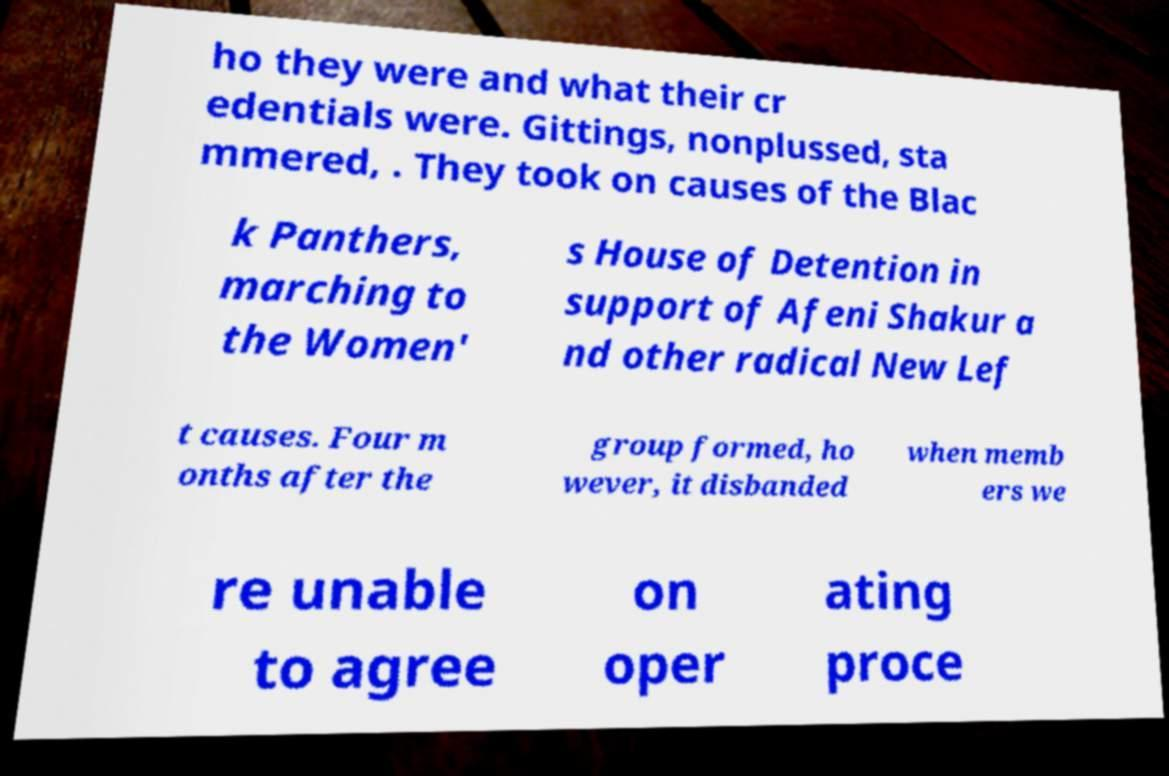Please identify and transcribe the text found in this image. ho they were and what their cr edentials were. Gittings, nonplussed, sta mmered, . They took on causes of the Blac k Panthers, marching to the Women' s House of Detention in support of Afeni Shakur a nd other radical New Lef t causes. Four m onths after the group formed, ho wever, it disbanded when memb ers we re unable to agree on oper ating proce 